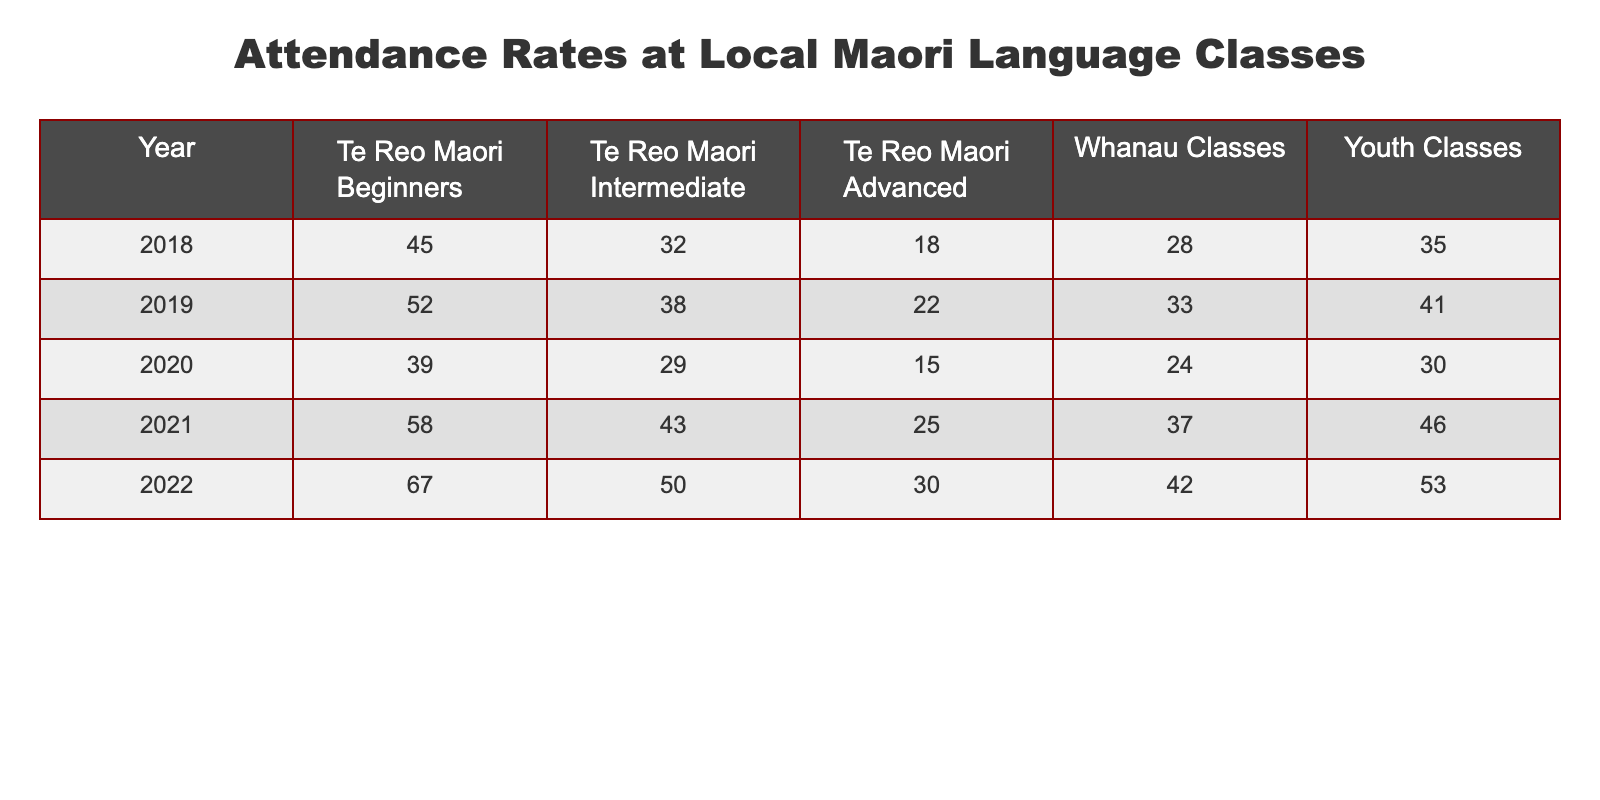What was the attendance for Te Reo Maori Advanced classes in 2022? The table shows that in 2022, the attendance for Te Reo Maori Advanced classes was 30.
Answer: 30 How many students attended Whanau Classes in 2019? According to the table for the year 2019, the attendance for Whanau Classes was 33.
Answer: 33 Did attendance for Te Reo Maori Beginners increase from 2018 to 2022? In 2018, the attendance was 45, and in 2022, it increased to 67. Since 67 is greater than 45, the attendance did increase.
Answer: Yes What is the average attendance for Youth Classes over the past 5 years? To find the average, sum the attendance for Youth Classes: (35 + 41 + 30 + 46 + 53) = 205. Then divide that sum by the number of years, which is 5. So, the average is 205 / 5 = 41.
Answer: 41 Which class had the highest attendance in 2021? In 2021, the attendance numbers were: Beginners 58, Intermediate 43, Advanced 25, Whanau 37, Youth 46. The highest attendance was for Te Reo Maori Beginners, which had 58 attendees.
Answer: Te Reo Maori Beginners 